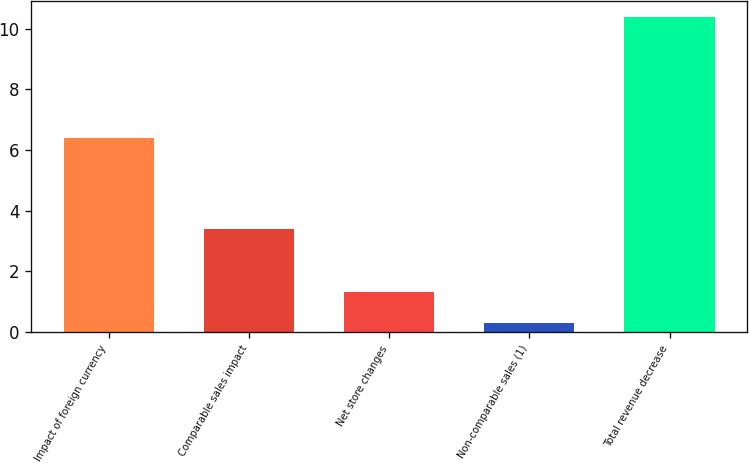<chart> <loc_0><loc_0><loc_500><loc_500><bar_chart><fcel>Impact of foreign currency<fcel>Comparable sales impact<fcel>Net store changes<fcel>Non-comparable sales (1)<fcel>Total revenue decrease<nl><fcel>6.4<fcel>3.4<fcel>1.31<fcel>0.3<fcel>10.4<nl></chart> 